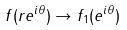<formula> <loc_0><loc_0><loc_500><loc_500>f ( r e ^ { i \theta } ) \rightarrow f _ { 1 } ( e ^ { i \theta } )</formula> 